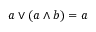<formula> <loc_0><loc_0><loc_500><loc_500>a \vee ( a \wedge b ) = a</formula> 